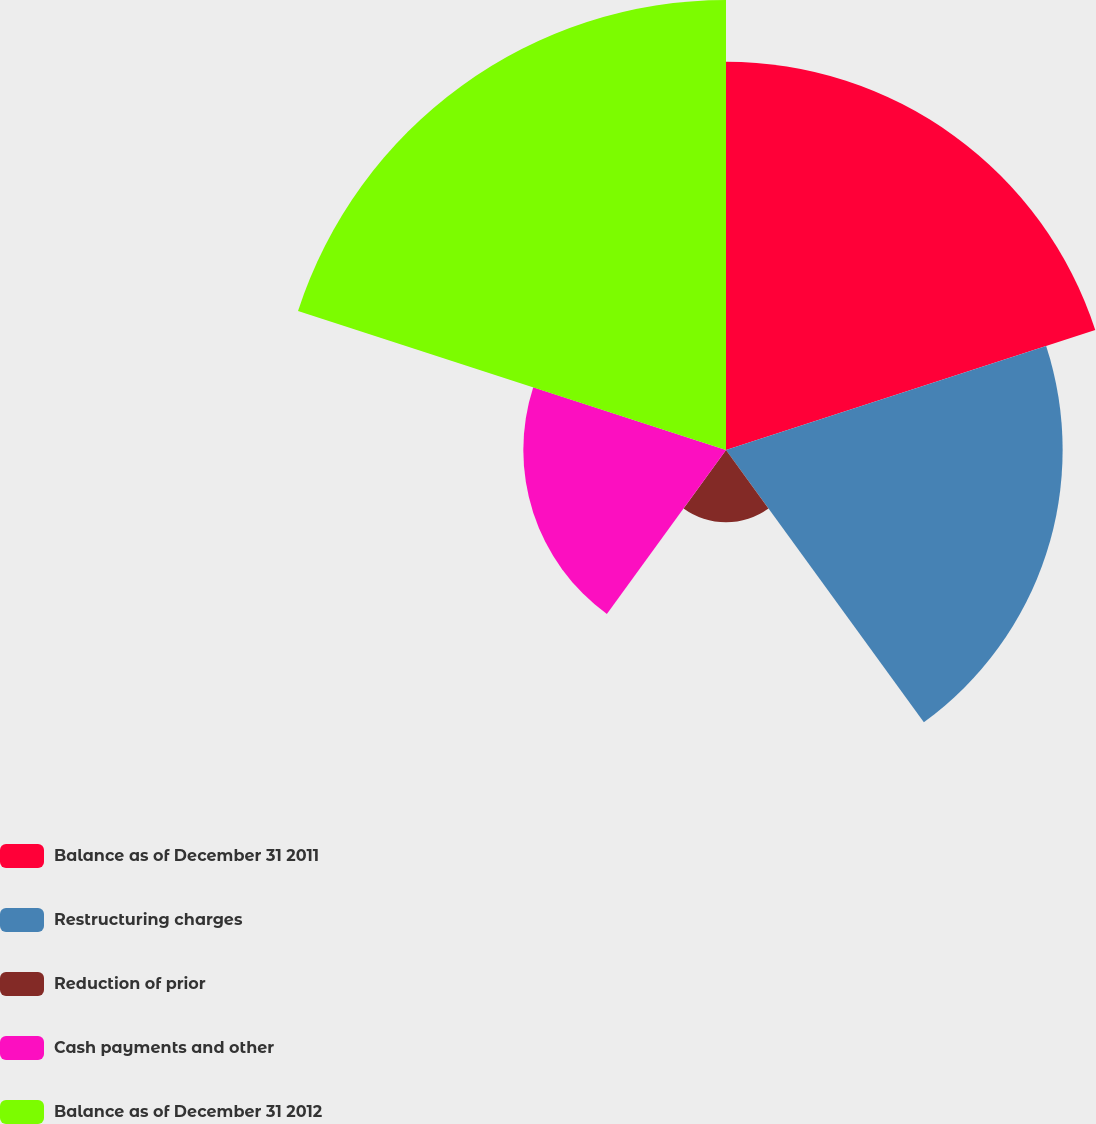Convert chart to OTSL. <chart><loc_0><loc_0><loc_500><loc_500><pie_chart><fcel>Balance as of December 31 2011<fcel>Restructuring charges<fcel>Reduction of prior<fcel>Cash payments and other<fcel>Balance as of December 31 2012<nl><fcel>26.78%<fcel>23.22%<fcel>4.98%<fcel>13.98%<fcel>31.04%<nl></chart> 